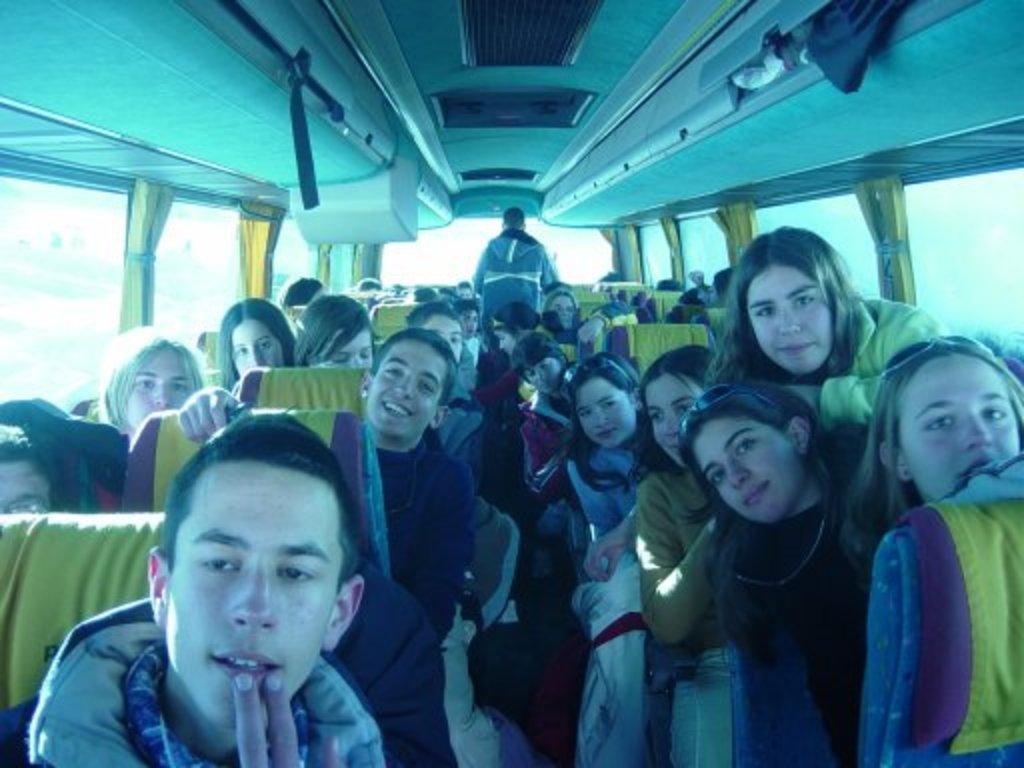Could you give a brief overview of what you see in this image? This is the inside view of a vehicle. There are few persons sitting on the seats and two persons are standing. On the left and right side we can see window glasses and curtains. 